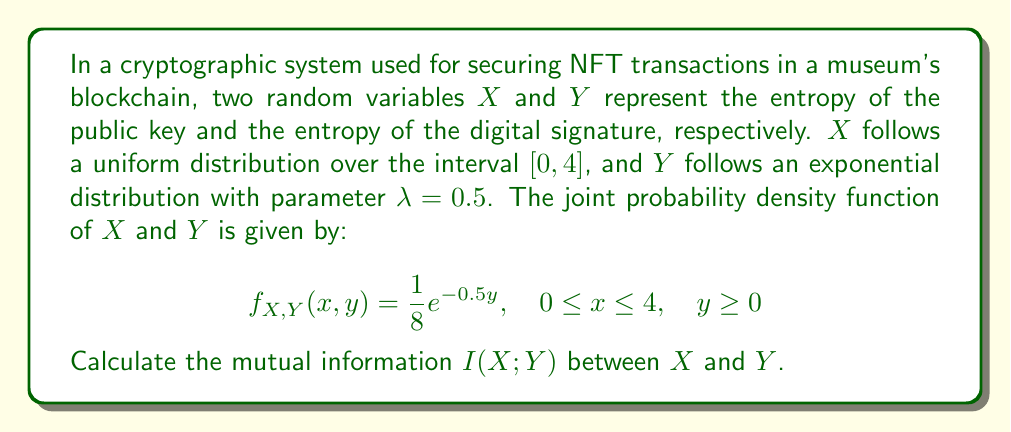What is the answer to this math problem? To calculate the mutual information I(X;Y), we need to follow these steps:

1. Find the marginal probability density functions (PDFs) of X and Y.
2. Calculate the entropies H(X) and H(Y).
3. Calculate the joint entropy H(X,Y).
4. Use the formula: I(X;Y) = H(X) + H(Y) - H(X,Y)

Step 1: Marginal PDFs

For X: $f_X(x) = \int_0^\infty f_{X,Y}(x,y) dy = \int_0^\infty \frac{1}{8}e^{-0.5y} dy = \frac{1}{4}, \quad 0 \leq x \leq 4$

For Y: $f_Y(y) = \int_0^4 f_{X,Y}(x,y) dx = \int_0^4 \frac{1}{8}e^{-0.5y} dx = \frac{1}{2}e^{-0.5y}, \quad y \geq 0$

Step 2: Entropies

H(X) = $-\int_0^4 f_X(x) \log_2 f_X(x) dx = -\int_0^4 \frac{1}{4} \log_2 \frac{1}{4} dx = 2$ bits

H(Y) = $-\int_0^\infty f_Y(y) \log_2 f_Y(y) dy = -\int_0^\infty \frac{1}{2}e^{-0.5y} \log_2 (\frac{1}{2}e^{-0.5y}) dy$
     $= 1 + \log_2(e) \approx 2.443$ bits

Step 3: Joint entropy

H(X,Y) = $-\int_0^4 \int_0^\infty f_{X,Y}(x,y) \log_2 f_{X,Y}(x,y) dy dx$
       $= -\int_0^4 \int_0^\infty \frac{1}{8}e^{-0.5y} \log_2 (\frac{1}{8}e^{-0.5y}) dy dx$
       $= 3 + \log_2(e) \approx 4.443$ bits

Step 4: Mutual information

I(X;Y) = H(X) + H(Y) - H(X,Y)
       $= 2 + (1 + \log_2(e)) - (3 + \log_2(e))$
       $= 0$ bits
Answer: The mutual information I(X;Y) = 0 bits 